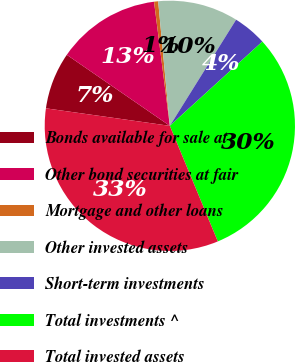Convert chart. <chart><loc_0><loc_0><loc_500><loc_500><pie_chart><fcel>Bonds available for sale at<fcel>Other bond securities at fair<fcel>Mortgage and other loans<fcel>Other invested assets<fcel>Short-term investments<fcel>Total investments ^<fcel>Total invested assets<nl><fcel>7.37%<fcel>13.38%<fcel>0.53%<fcel>10.37%<fcel>4.36%<fcel>30.5%<fcel>33.5%<nl></chart> 